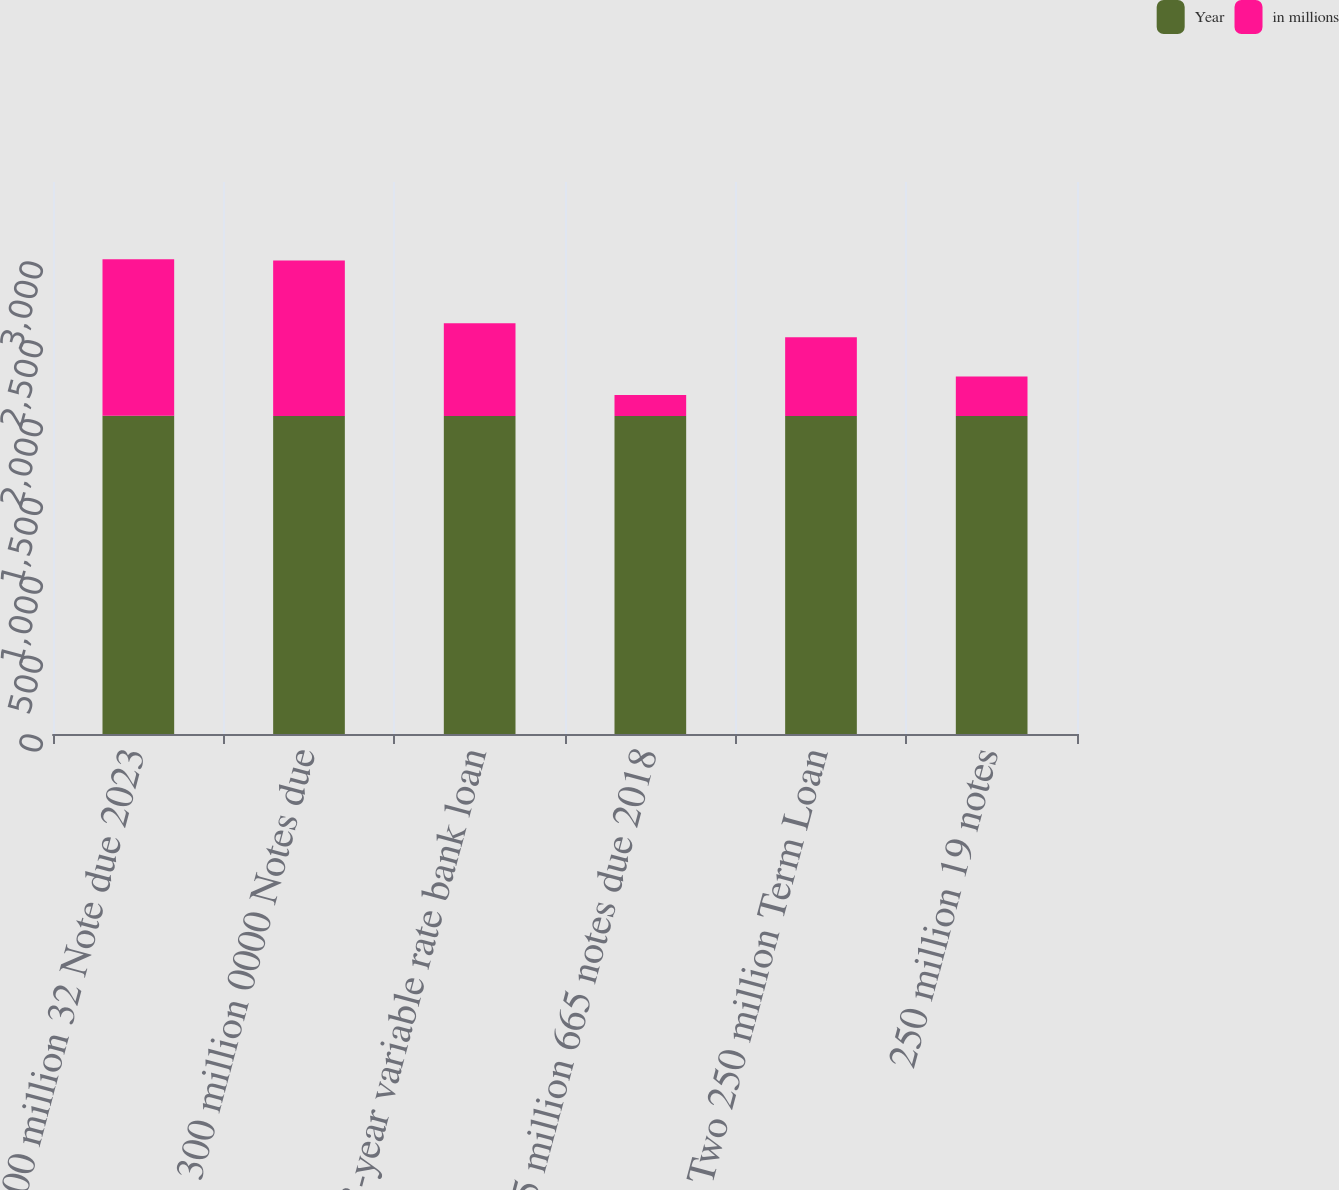<chart> <loc_0><loc_0><loc_500><loc_500><stacked_bar_chart><ecel><fcel>300 million 32 Note due 2023<fcel>300 million 0000 Notes due<fcel>3-year variable rate bank loan<fcel>125 million 665 notes due 2018<fcel>Two 250 million Term Loan<fcel>250 million 19 notes<nl><fcel>Year<fcel>2018<fcel>2016<fcel>2017<fcel>2016<fcel>2016<fcel>2016<nl><fcel>in millions<fcel>992<fcel>987<fcel>587<fcel>133<fcel>500<fcel>250<nl></chart> 